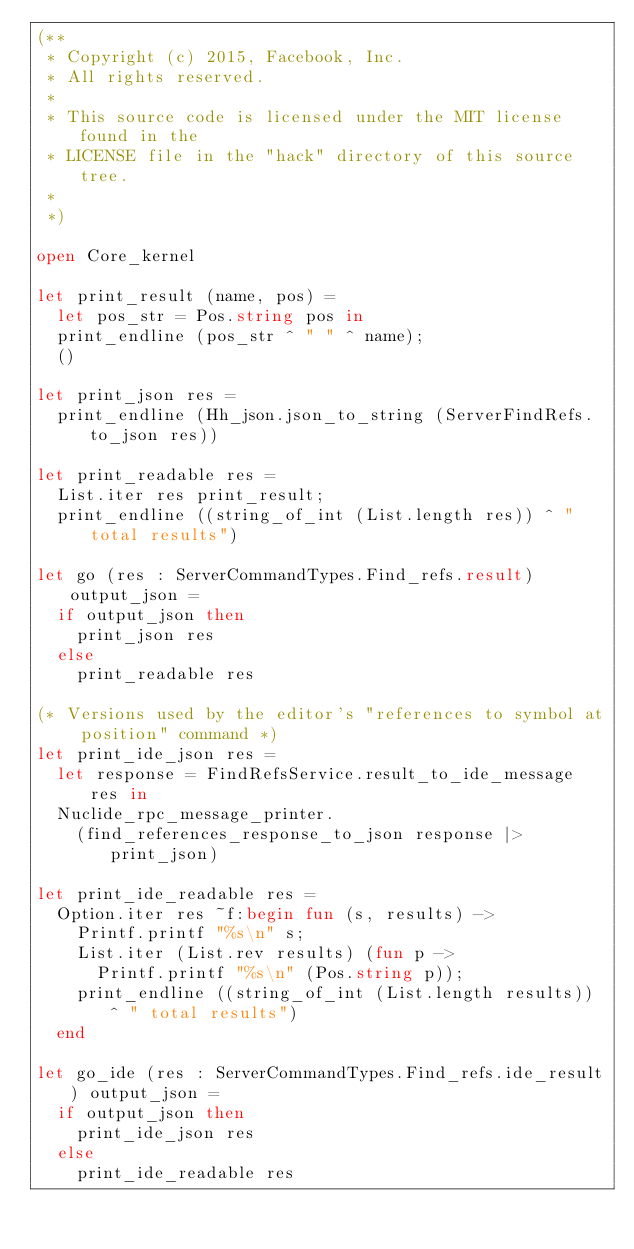<code> <loc_0><loc_0><loc_500><loc_500><_OCaml_>(**
 * Copyright (c) 2015, Facebook, Inc.
 * All rights reserved.
 *
 * This source code is licensed under the MIT license found in the
 * LICENSE file in the "hack" directory of this source tree.
 *
 *)

open Core_kernel

let print_result (name, pos) =
  let pos_str = Pos.string pos in
  print_endline (pos_str ^ " " ^ name);
  ()

let print_json res =
  print_endline (Hh_json.json_to_string (ServerFindRefs.to_json res))

let print_readable res =
  List.iter res print_result;
  print_endline ((string_of_int (List.length res)) ^ " total results")

let go (res : ServerCommandTypes.Find_refs.result) output_json =
  if output_json then
    print_json res
  else
    print_readable res

(* Versions used by the editor's "references to symbol at position" command *)
let print_ide_json res =
  let response = FindRefsService.result_to_ide_message res in
  Nuclide_rpc_message_printer.
    (find_references_response_to_json response |> print_json)

let print_ide_readable res =
  Option.iter res ~f:begin fun (s, results) ->
    Printf.printf "%s\n" s;
    List.iter (List.rev results) (fun p ->
      Printf.printf "%s\n" (Pos.string p));
    print_endline ((string_of_int (List.length results)) ^ " total results")
  end

let go_ide (res : ServerCommandTypes.Find_refs.ide_result) output_json =
  if output_json then
    print_ide_json res
  else
    print_ide_readable res
</code> 